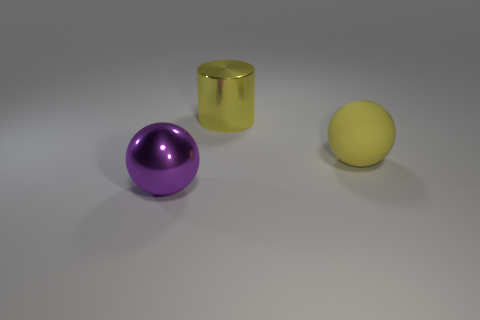Add 2 large gray metal things. How many objects exist? 5 Subtract all balls. How many objects are left? 1 Add 2 yellow rubber spheres. How many yellow rubber spheres are left? 3 Add 2 yellow rubber objects. How many yellow rubber objects exist? 3 Subtract 0 cyan blocks. How many objects are left? 3 Subtract all big purple shiny balls. Subtract all yellow metallic objects. How many objects are left? 1 